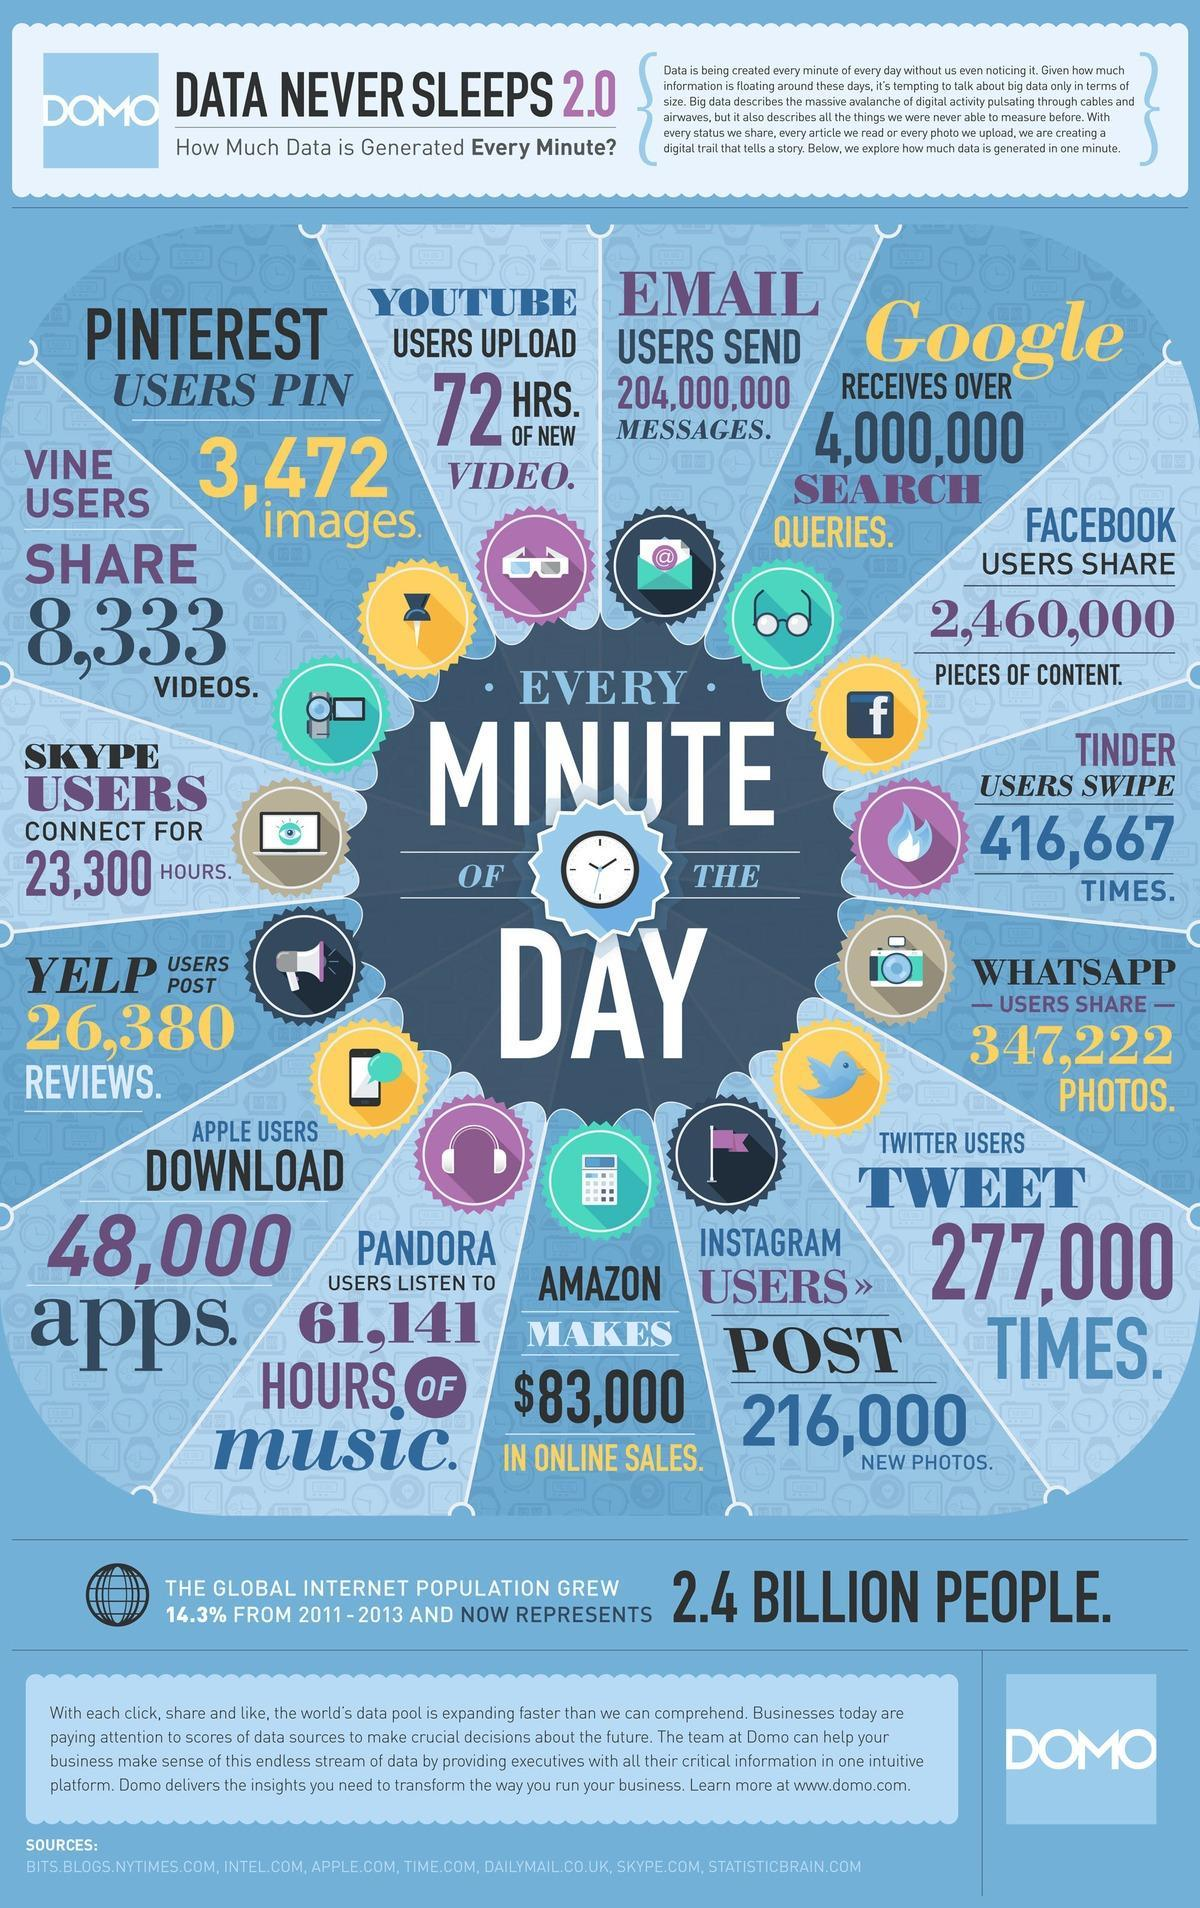How many posts/photos forward happen in Whatsapp in a single minute?
Answer the question with a short phrase. 347,222 How many posts are getting shared in Facebook in a minute? 2,460,000 pieces of content How many videos are shared through Vine in a minute? 8,333 videos What is the worth of Amazon Online shopping in a single minute? $83,000 in online sales How many Tweets come in every single minute in Twitter? 277,000 How many emails are getting send in a minute? 204,000,000 messages How many post occurs in a minute in Instagram? 216,000 new photos How many searches happen in Google in a single minute? 4,000,000 In which social media platform 26,380 post reviews happen in a single minute? Yelp How many pictures are being pinned in every minute in Pinterest? 3,472 images 